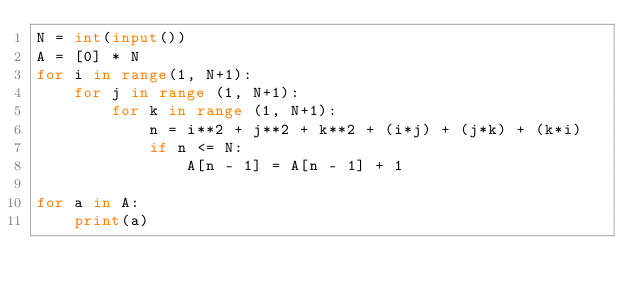Convert code to text. <code><loc_0><loc_0><loc_500><loc_500><_Python_>N = int(input())
A = [0] * N
for i in range(1, N+1):
    for j in range (1, N+1):
        for k in range (1, N+1):
            n = i**2 + j**2 + k**2 + (i*j) + (j*k) + (k*i)
            if n <= N:
                A[n - 1] = A[n - 1] + 1

for a in A:
    print(a)</code> 